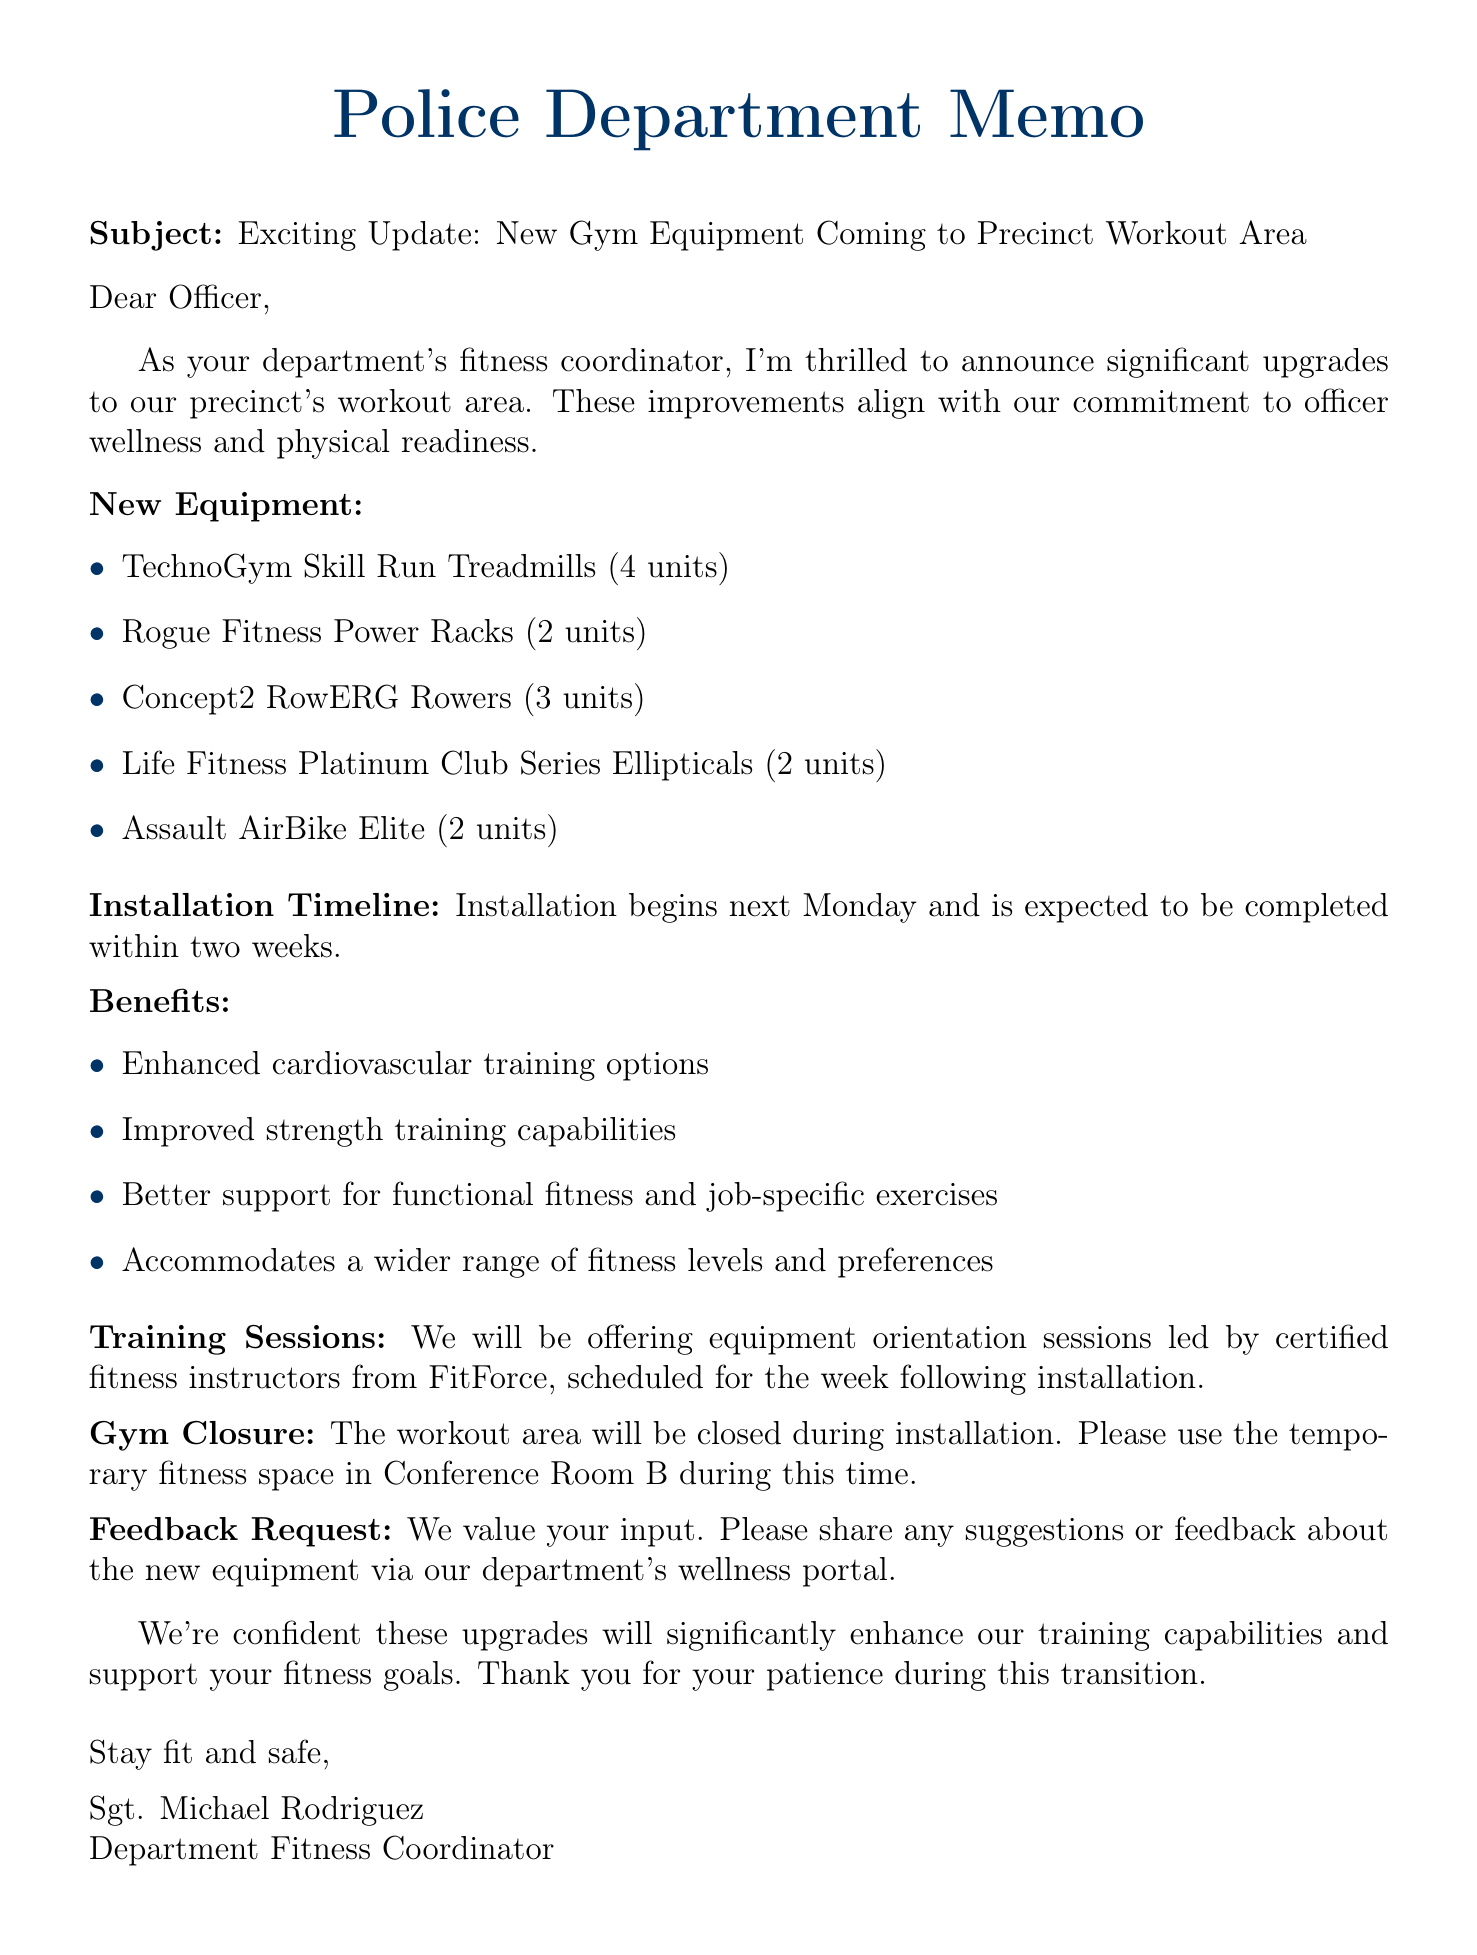What is the subject of the email? The subject is clearly stated at the beginning of the email as "Exciting Update: New Gym Equipment Coming to Precinct Workout Area."
Answer: Exciting Update: New Gym Equipment Coming to Precinct Workout Area How many treadmills are being installed? The document lists the new equipment and specifies that there are 4 TechnoGym Skill Run Treadmills being installed.
Answer: 4 When does the installation begin? The installation timeline states that the installation begins next Monday.
Answer: Next Monday What temporary space should be used during gym closure? The document mentions using Conference Room B as a temporary fitness space during the installation of the new equipment.
Answer: Conference Room B What benefits are provided by the new equipment? The benefits section outlines several improvements, including enhanced cardiovascular training options, which is one of the points listed.
Answer: Enhanced cardiovascular training options Who will lead the equipment orientation sessions? The document specifies that certified fitness instructors from FitForce will lead the equipment orientation sessions.
Answer: FitForce How many weeks is the installation expected to take? The installation timeline indicates that installation is expected to be completed within two weeks.
Answer: Two weeks What is requested from officers regarding the new equipment? The document has a section that requests officers to share suggestions or feedback about the new equipment via the wellness portal.
Answer: Suggestions or feedback 